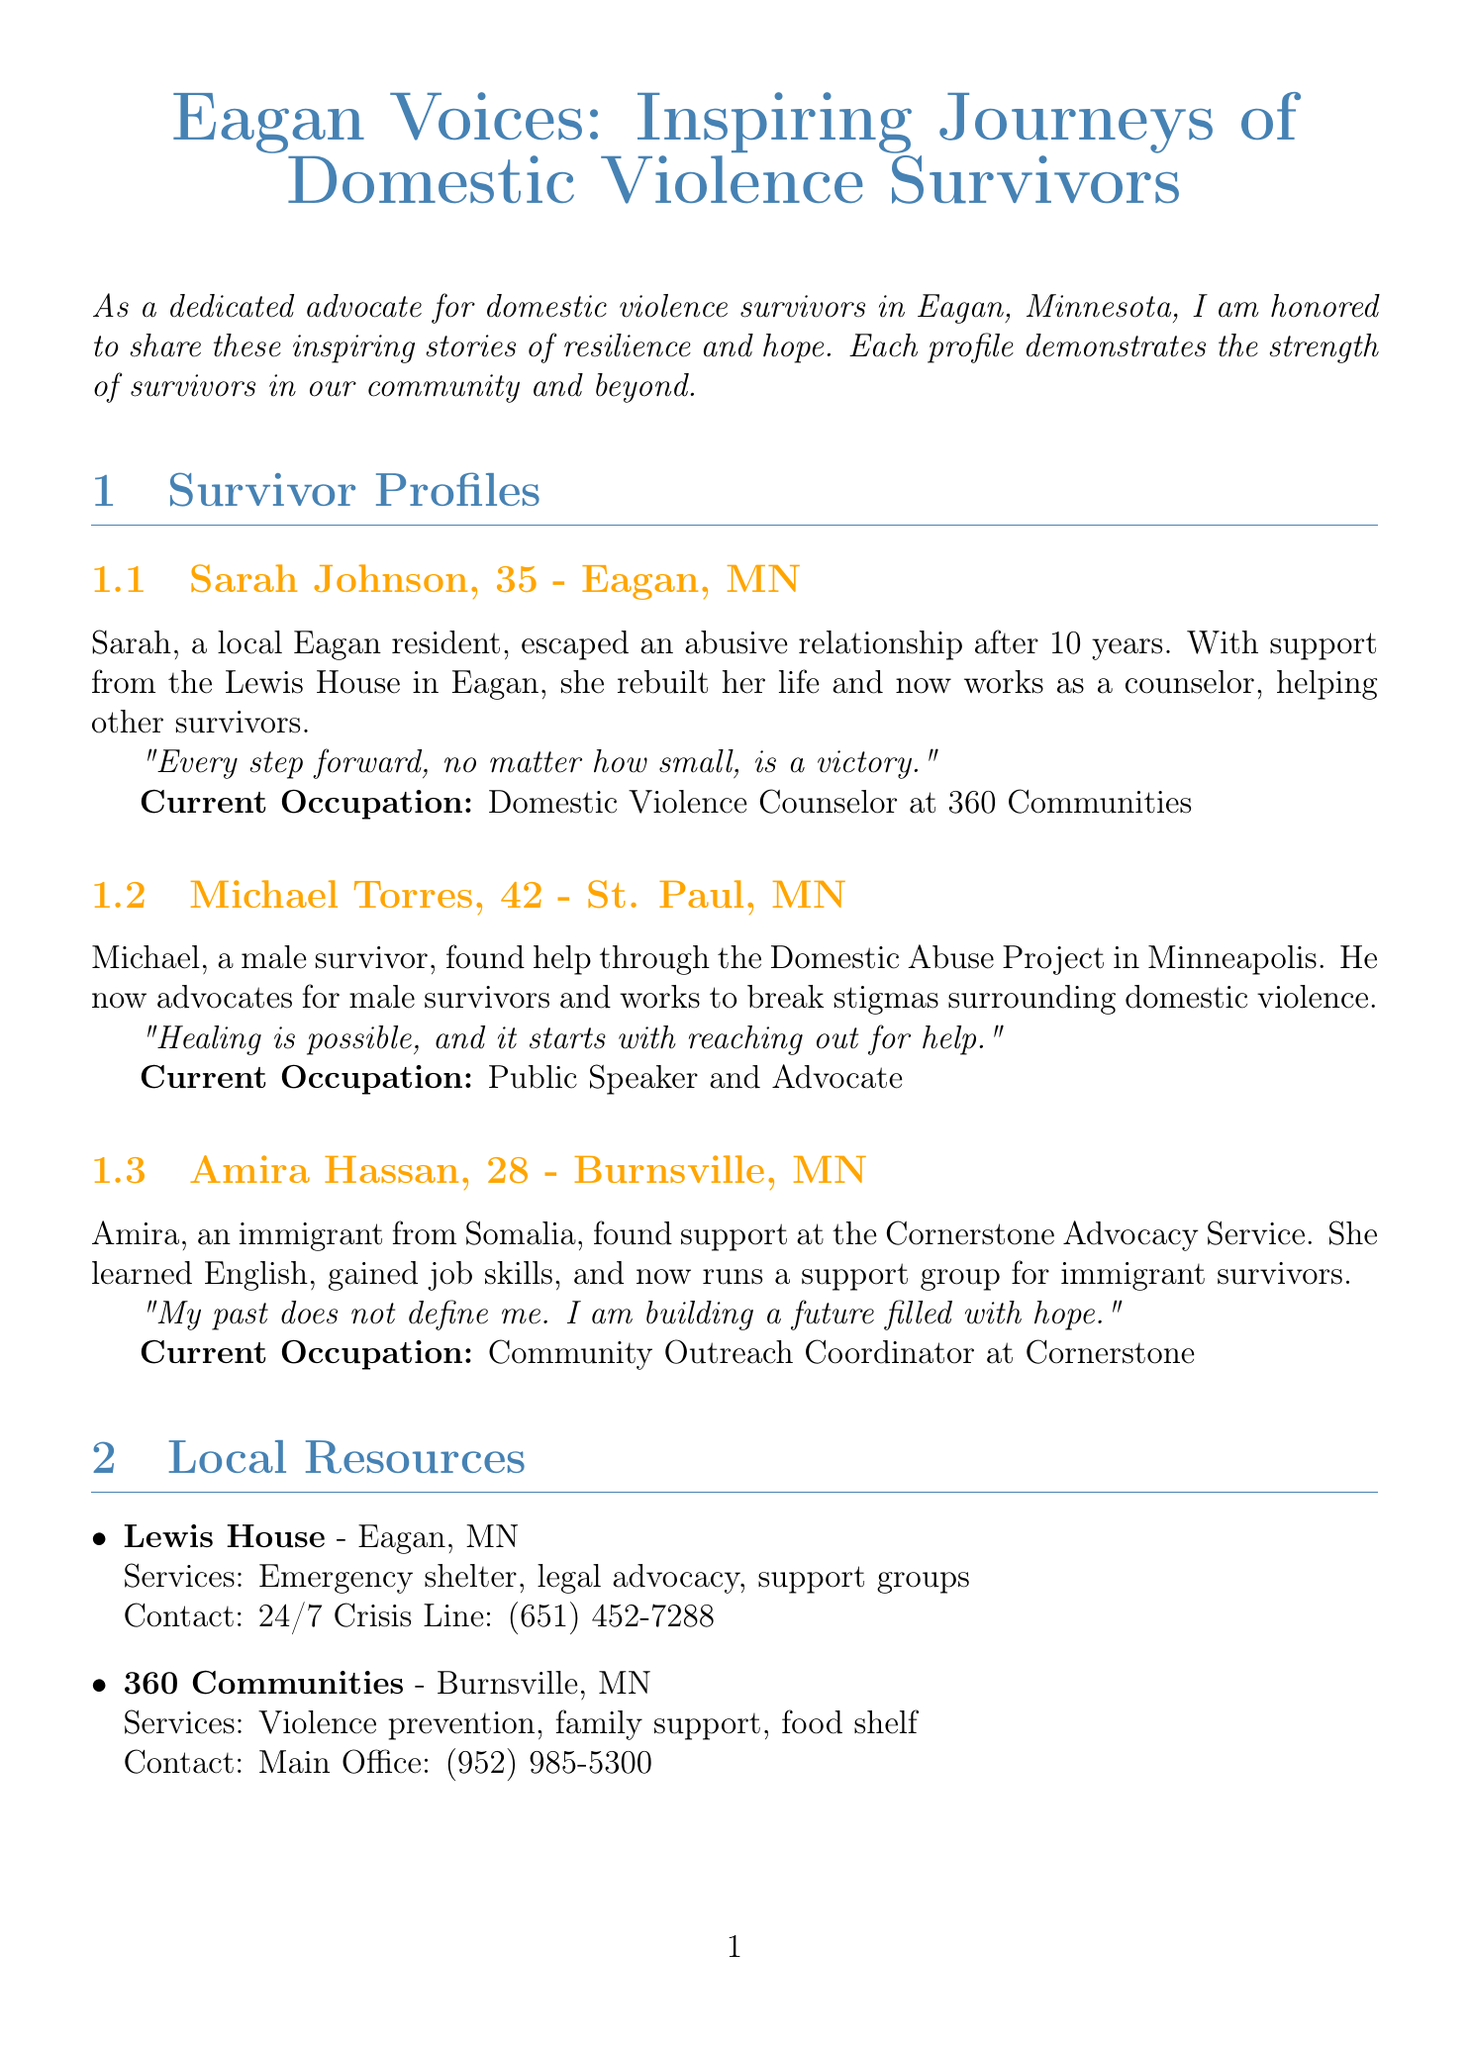What is the title of the newsletter? The title appears at the beginning of the document and is a central feature of the newsletter.
Answer: Eagan Voices: Inspiring Journeys of Domestic Violence Survivors Who is the first survivor featured in the profiles? The profiles section lists individual survivors, starting with the first one.
Answer: Sarah Johnson What organization did Sarah Johnson receive support from? The document specifies the organizations from which the survivors received support.
Answer: Lewis House What is Michael Torres' current occupation? Each survivor's profile includes their current occupation.
Answer: Public Speaker and Advocate When is the "Walk a Mile in Her Shoes" event scheduled? The upcoming events section details the dates of specific events.
Answer: June 15, 2023 How many years did Sarah escape from an abusive relationship? Sarah's profile mentions the duration of her abusive experience distinctly.
Answer: 10 years What service does Dakota County Domestic Violence Services provide? The document lists the services offered by local resources.
Answer: Court advocacy Which location is the "Survivor Art Exhibition" taking place? The document specifies locations for events listed in the upcoming events section.
Answer: Eagan Art House What is the contact number for Lewis House? The local resources section provides contact information for support services.
Answer: 24/7 Crisis Line: (651) 452-7288 